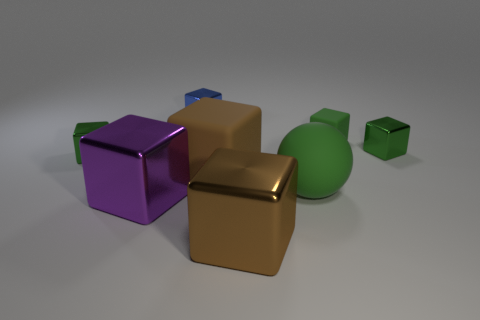What is the material of the other small blue thing that is the same shape as the small rubber thing?
Ensure brevity in your answer.  Metal. Does the tiny shiny thing that is behind the small rubber thing have the same color as the rubber object that is on the left side of the big matte sphere?
Your answer should be very brief. No. Is there a brown matte cube of the same size as the purple metal object?
Offer a terse response. Yes. What is the material of the green object that is behind the big green matte sphere and to the left of the small green matte block?
Your response must be concise. Metal. What number of rubber things are either large brown objects or tiny gray spheres?
Give a very brief answer. 1. What number of metal things are in front of the small green matte cube and to the left of the big brown metallic object?
Your answer should be compact. 2. Is there anything else that is the same shape as the blue thing?
Provide a succinct answer. Yes. What size is the green object left of the brown matte object?
Your answer should be compact. Small. How many other things are the same color as the tiny rubber thing?
Your response must be concise. 3. The small green object that is left of the brown cube in front of the big purple shiny cube is made of what material?
Your answer should be very brief. Metal. 